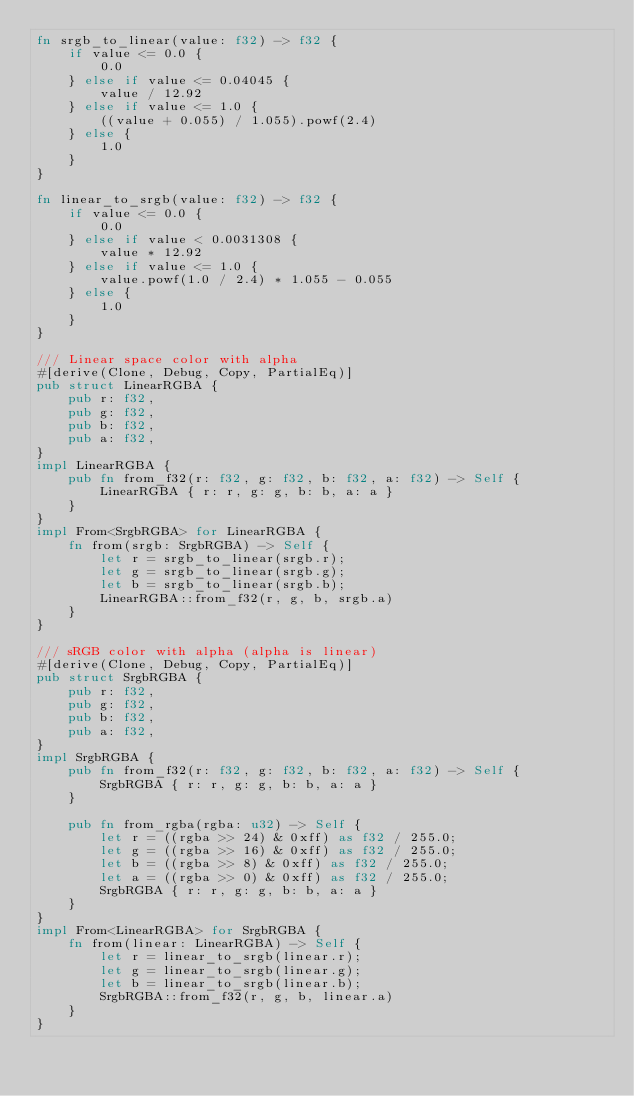<code> <loc_0><loc_0><loc_500><loc_500><_Rust_>fn srgb_to_linear(value: f32) -> f32 {
    if value <= 0.0 {
        0.0
    } else if value <= 0.04045 {
        value / 12.92
    } else if value <= 1.0 {
        ((value + 0.055) / 1.055).powf(2.4)
    } else {
        1.0
    }
}

fn linear_to_srgb(value: f32) -> f32 {
    if value <= 0.0 {
        0.0
    } else if value < 0.0031308 {
        value * 12.92
    } else if value <= 1.0 {
        value.powf(1.0 / 2.4) * 1.055 - 0.055
    } else {
        1.0
    }
}

/// Linear space color with alpha
#[derive(Clone, Debug, Copy, PartialEq)]
pub struct LinearRGBA {
    pub r: f32,
    pub g: f32,
    pub b: f32,
    pub a: f32,
}
impl LinearRGBA {
    pub fn from_f32(r: f32, g: f32, b: f32, a: f32) -> Self {
        LinearRGBA { r: r, g: g, b: b, a: a }
    }
}
impl From<SrgbRGBA> for LinearRGBA {
    fn from(srgb: SrgbRGBA) -> Self {
        let r = srgb_to_linear(srgb.r);
        let g = srgb_to_linear(srgb.g);
        let b = srgb_to_linear(srgb.b);
        LinearRGBA::from_f32(r, g, b, srgb.a)
    }
}

/// sRGB color with alpha (alpha is linear)
#[derive(Clone, Debug, Copy, PartialEq)]
pub struct SrgbRGBA {
    pub r: f32,
    pub g: f32,
    pub b: f32,
    pub a: f32,
}
impl SrgbRGBA {
    pub fn from_f32(r: f32, g: f32, b: f32, a: f32) -> Self {
        SrgbRGBA { r: r, g: g, b: b, a: a }
    }

    pub fn from_rgba(rgba: u32) -> Self {
        let r = ((rgba >> 24) & 0xff) as f32 / 255.0;
        let g = ((rgba >> 16) & 0xff) as f32 / 255.0;
        let b = ((rgba >> 8) & 0xff) as f32 / 255.0;
        let a = ((rgba >> 0) & 0xff) as f32 / 255.0;
        SrgbRGBA { r: r, g: g, b: b, a: a }
    }
}
impl From<LinearRGBA> for SrgbRGBA {
    fn from(linear: LinearRGBA) -> Self {
        let r = linear_to_srgb(linear.r);
        let g = linear_to_srgb(linear.g);
        let b = linear_to_srgb(linear.b);
        SrgbRGBA::from_f32(r, g, b, linear.a)
    }
}
</code> 